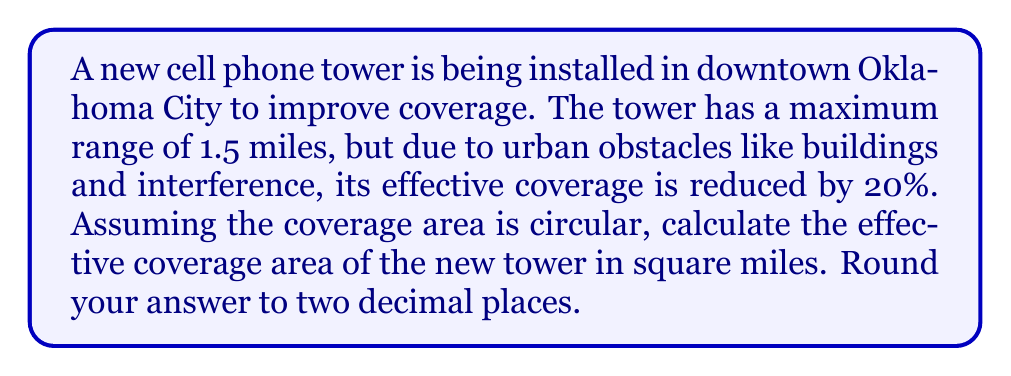Give your solution to this math problem. Let's approach this step-by-step:

1) First, we need to determine the effective radius of the tower's coverage.
   - Maximum range = 1.5 miles
   - Reduction due to urban obstacles = 20% = 0.2
   - Effective radius = $1.5 \times (1 - 0.2) = 1.5 \times 0.8 = 1.2$ miles

2) Now that we have the effective radius, we can calculate the area using the formula for the area of a circle:
   $$A = \pi r^2$$
   where $A$ is the area and $r$ is the radius.

3) Plugging in our effective radius:
   $$A = \pi \times (1.2)^2$$

4) Let's calculate this:
   $$A = \pi \times 1.44 \approx 4.5238934$ square miles

5) Rounding to two decimal places:
   $A \approx 4.52$ square miles

This represents the effective coverage area of the new cell phone tower in downtown Oklahoma City, taking into account the urban environment's impact on signal propagation.
Answer: 4.52 square miles 